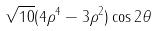Convert formula to latex. <formula><loc_0><loc_0><loc_500><loc_500>\sqrt { 1 0 } ( 4 \rho ^ { 4 } - 3 \rho ^ { 2 } ) \cos 2 \theta</formula> 